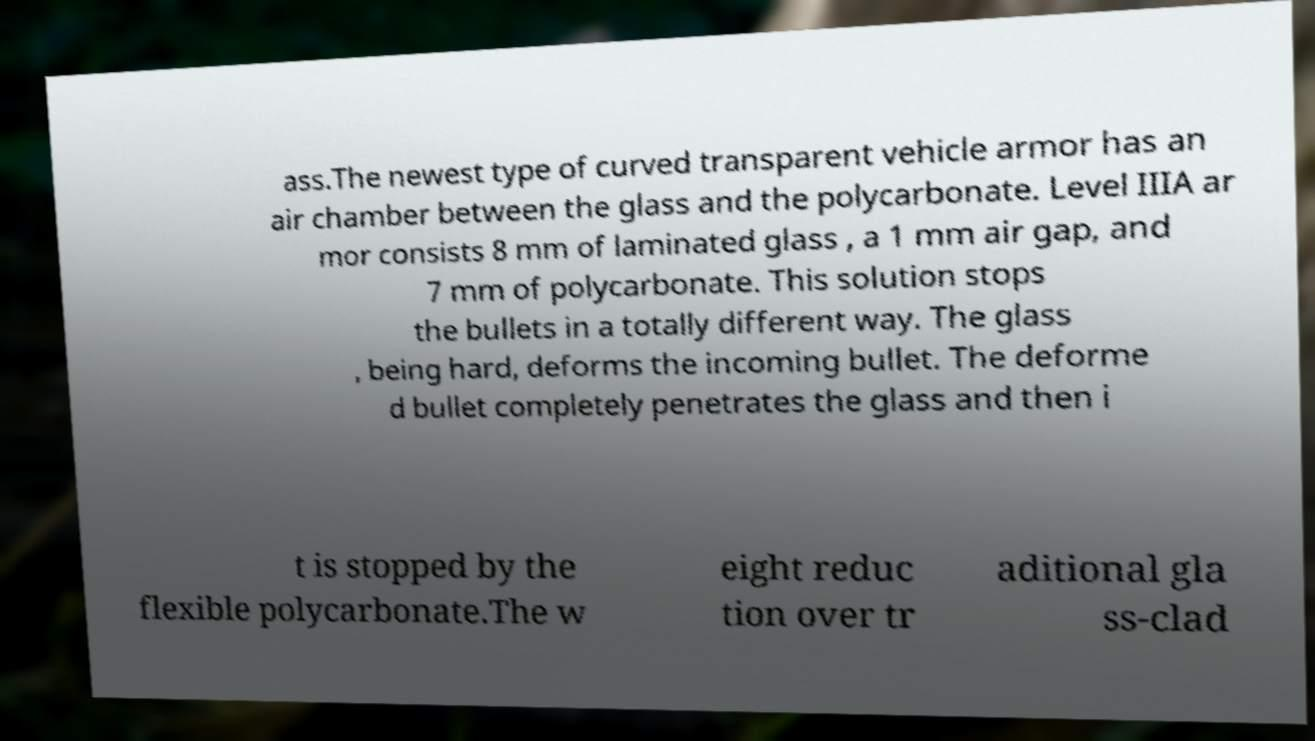For documentation purposes, I need the text within this image transcribed. Could you provide that? ass.The newest type of curved transparent vehicle armor has an air chamber between the glass and the polycarbonate. Level IIIA ar mor consists 8 mm of laminated glass , a 1 mm air gap, and 7 mm of polycarbonate. This solution stops the bullets in a totally different way. The glass , being hard, deforms the incoming bullet. The deforme d bullet completely penetrates the glass and then i t is stopped by the flexible polycarbonate.The w eight reduc tion over tr aditional gla ss-clad 